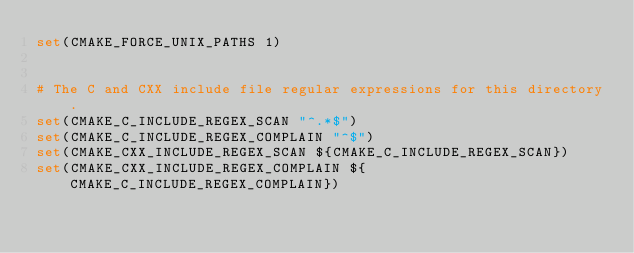Convert code to text. <code><loc_0><loc_0><loc_500><loc_500><_CMake_>set(CMAKE_FORCE_UNIX_PATHS 1)


# The C and CXX include file regular expressions for this directory.
set(CMAKE_C_INCLUDE_REGEX_SCAN "^.*$")
set(CMAKE_C_INCLUDE_REGEX_COMPLAIN "^$")
set(CMAKE_CXX_INCLUDE_REGEX_SCAN ${CMAKE_C_INCLUDE_REGEX_SCAN})
set(CMAKE_CXX_INCLUDE_REGEX_COMPLAIN ${CMAKE_C_INCLUDE_REGEX_COMPLAIN})
</code> 